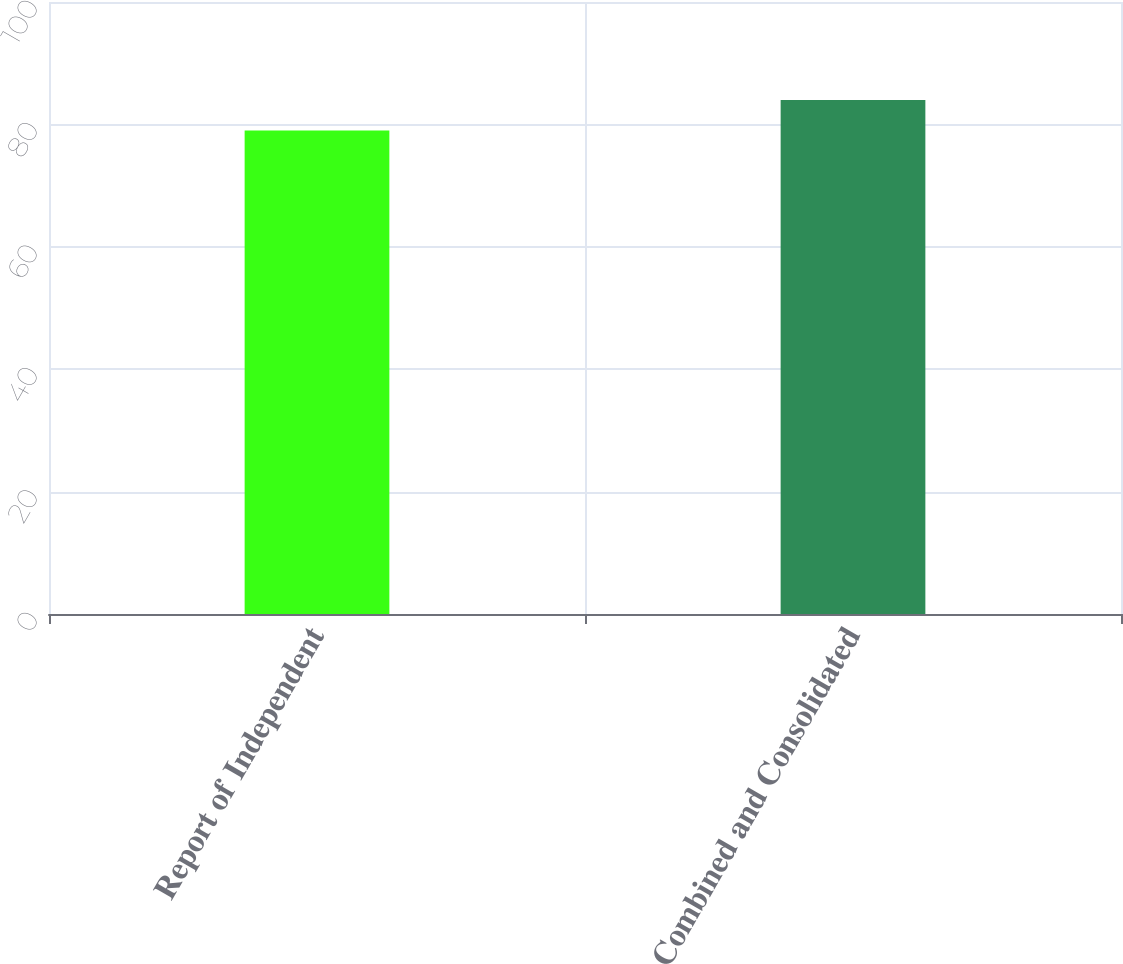<chart> <loc_0><loc_0><loc_500><loc_500><bar_chart><fcel>Report of Independent<fcel>Combined and Consolidated<nl><fcel>79<fcel>84<nl></chart> 